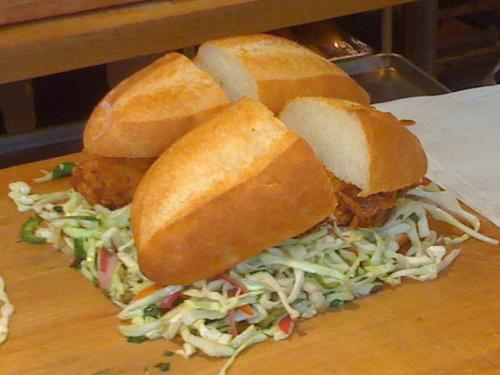How many people is this food for most likely?
Pick the correct solution from the four options below to address the question.
Options: Eight, two, one, twenty. Two. 